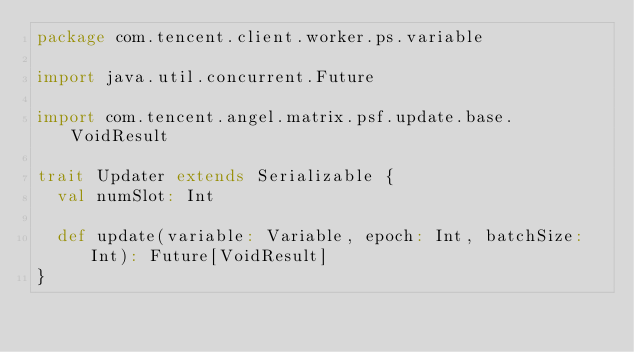<code> <loc_0><loc_0><loc_500><loc_500><_Scala_>package com.tencent.client.worker.ps.variable

import java.util.concurrent.Future

import com.tencent.angel.matrix.psf.update.base.VoidResult

trait Updater extends Serializable {
  val numSlot: Int

  def update(variable: Variable, epoch: Int, batchSize: Int): Future[VoidResult]
}</code> 